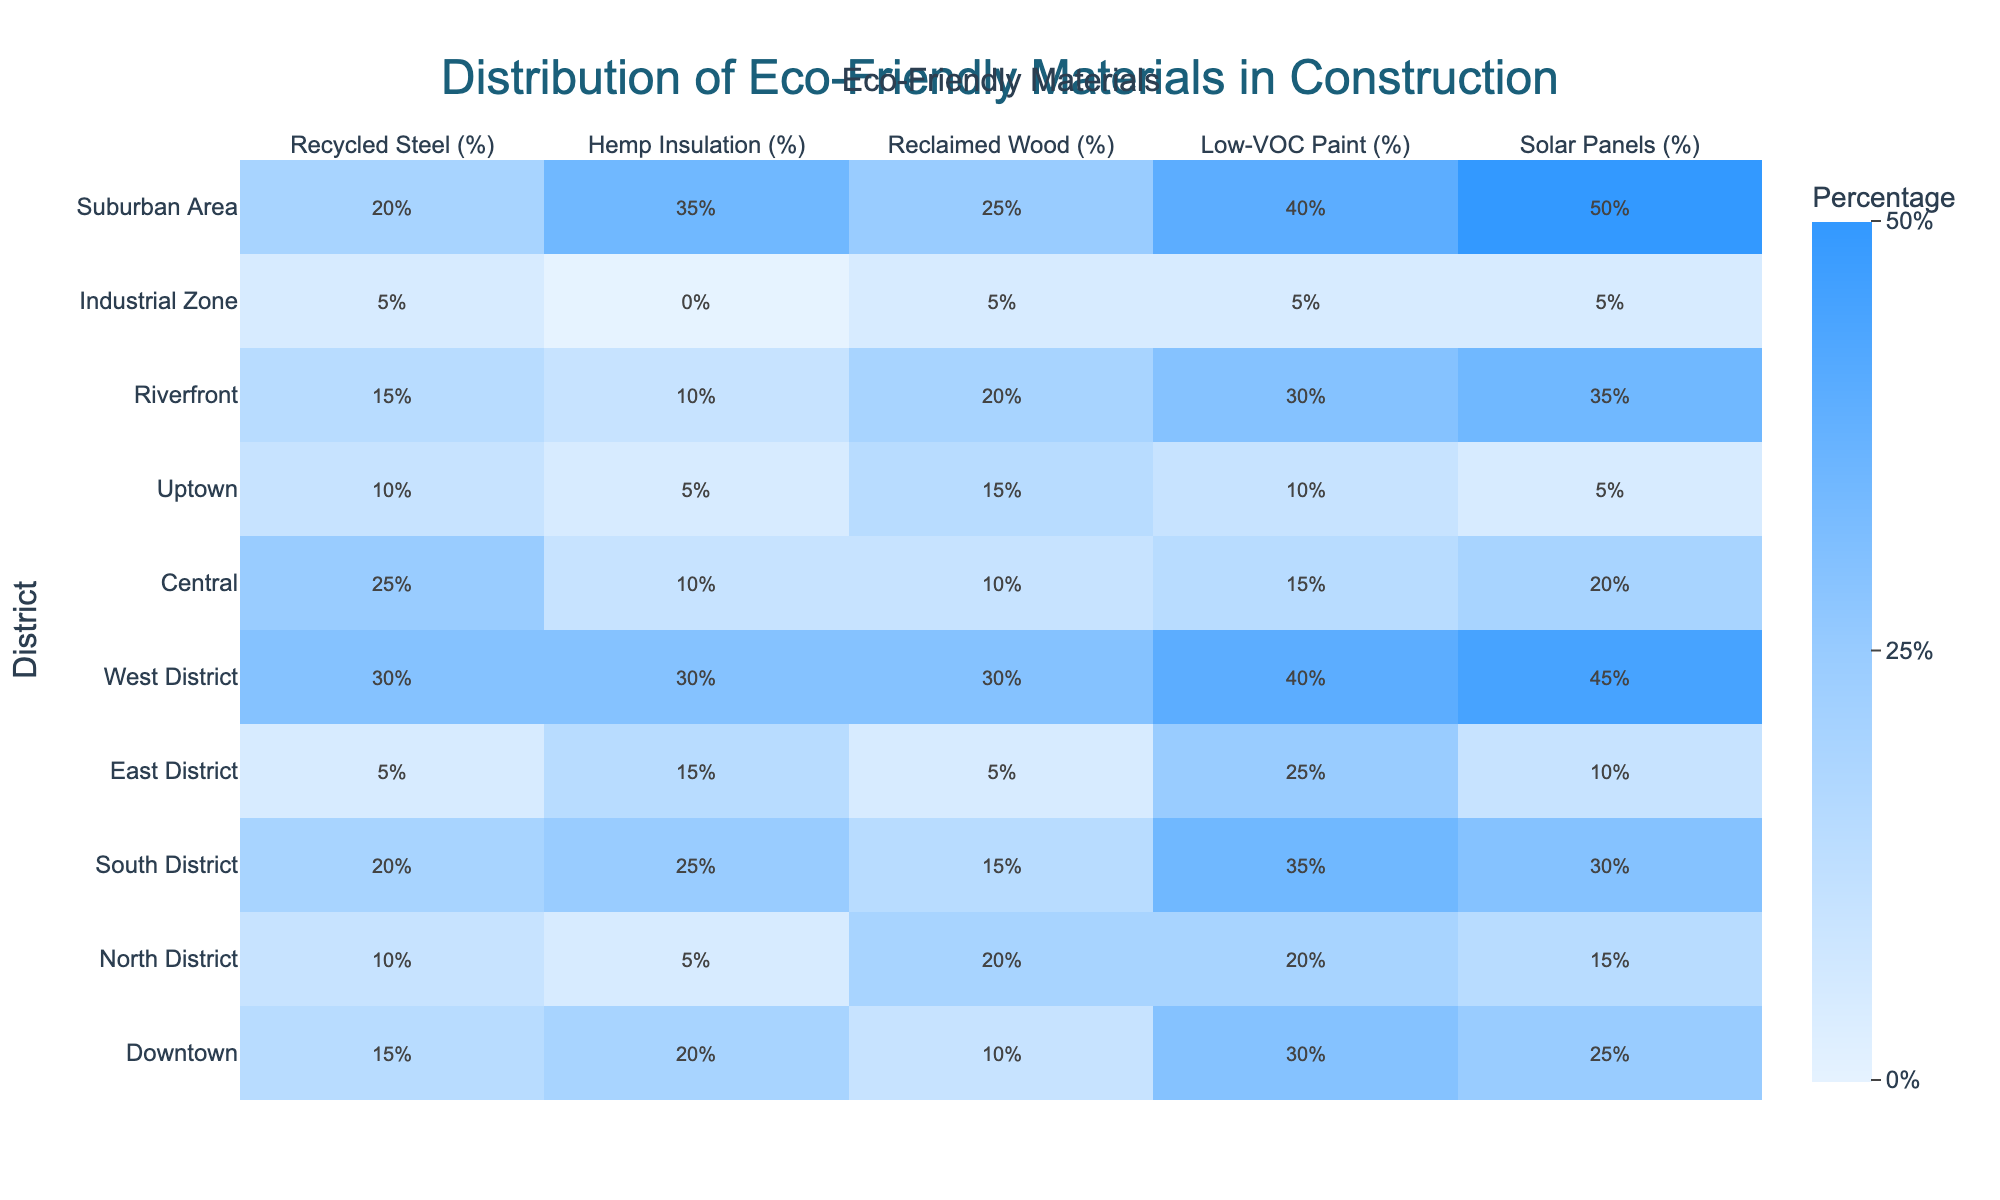What is the highest percentage of Low-VOC Paint used in any district? The percentages of Low-VOC Paint for each district are as follows: Downtown 30%, North District 20%, South District 35%, East District 25%, West District 40%, Central 15%, Uptown 10%, Riverfront 30%, Industrial Zone 5%, and Suburban Area 40%. The highest percentage of Low-VOC Paint is 40%, found in both West District and Suburban Area.
Answer: 40% Which district uses the least amount of Recycled Steel? Looking at the percentages of Recycled Steel, the values are: Downtown 15%, North District 10%, South District 20%, East District 5%, West District 30%, Central 25%, Uptown 10%, Riverfront 15%, Industrial Zone 5%, and Suburban Area 20%. The least amount of Recycled Steel is 5%, found in both East District and Industrial Zone.
Answer: 5% What is the average percentage of Hemp Insulation used across all districts? The Hemp Insulation percentages are: Downtown 20%, North District 5%, South District 25%, East District 15%, West District 30%, Central 10%, Uptown 5%, Riverfront 10%, and Suburban Area 35%. The sum of these percentages is 20 + 5 + 25 + 15 + 30 + 10 + 5 + 10 + 35 = 155. There are 9 districts, so the average is 155/9 ≈ 17.22%.
Answer: 17.22% Is there any district that uses both Solar Panels and at least 30% Low-VOC Paint? By checking the Solar Panel percentages along with the Low-VOC Paint percentages: Downtown 30% Paint and 25% Panels, North District 20% and 15%, South District 35% and 30%, East District 25% and 10%, West District 40% and 45%, Central 15% and 20%, Uptown 10% and 5%, Riverfront 30% and 35%, Industrial Zone 5% both. The districts with 30% Low-VOC Paint and Solar Panels are South District and West District. Yes, there are districts that meet this criterion.
Answer: Yes Which district has the highest combined percentage of Recycled Steel and Reclaimed Wood? The combined percentages for Recycled Steel and Reclaimed Wood are: Downtown (15 + 10) = 25%, North District (10 + 20) = 30%, South District (20 + 15) = 35%, East District (5 + 5) = 10%, West District (30 + 30) = 60%, Central (25 + 10) = 35%, Uptown (10 + 15) = 25%, Riverfront (15 + 20) = 35%, Industrial Zone (5 + 5) = 10%, Suburban Area (20 + 25) = 45%. The highest combined percentage is 60%, found in West District.
Answer: 60% Which eco-friendly material is most prevalent in the Industrial Zone? In the Industrial Zone, the percentages are: Recycled Steel 5%, Hemp Insulation 0%, Reclaimed Wood 5%, Low-VOC Paint 5%, and Solar Panels 5%. The most prevalent eco-friendly material at 5% is shared among all materials listed as they all have the same percentage.
Answer: 5% 